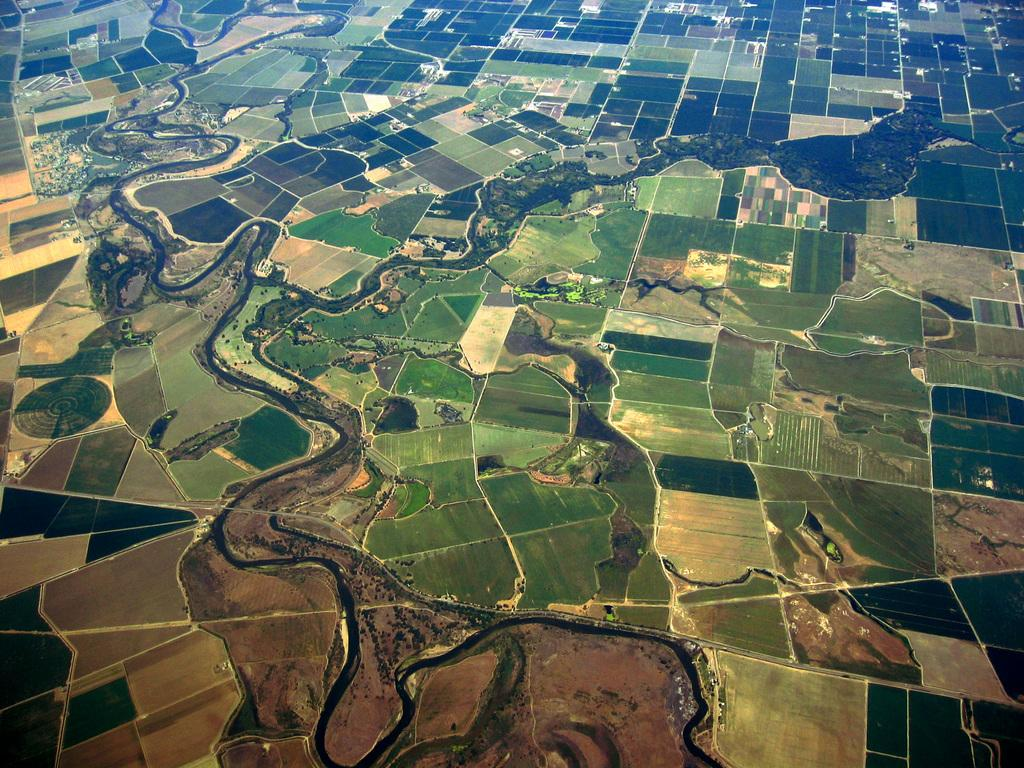What type of view is shown in the image? The image is an aerial view. What natural element can be seen in the image? There is water visible in the image. What type of land use is depicted in the image? Agriculture fields are present in the image. How many deer can be seen grazing in the agriculture fields in the image? There are no deer present in the image; it only shows water and agriculture fields. What type of spoon is used to mix the water in the image? There is no spoon present in the image, as it is an aerial view of water and agriculture fields. 